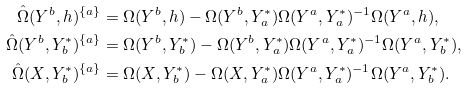Convert formula to latex. <formula><loc_0><loc_0><loc_500><loc_500>\hat { \Omega } ( Y ^ { b } , h ) ^ { \{ a \} } & = \Omega ( Y ^ { b } , h ) - \Omega ( Y ^ { b } , Y ^ { * } _ { a } ) \Omega ( Y ^ { a } , Y ^ { * } _ { a } ) ^ { - 1 } \Omega ( Y ^ { a } , h ) , \\ \hat { \Omega } ( Y ^ { b } , Y ^ { * } _ { b } ) ^ { \{ a \} } & = \Omega ( Y ^ { b } , Y ^ { * } _ { b } ) - \Omega ( Y ^ { b } , Y ^ { * } _ { a } ) \Omega ( Y ^ { a } , Y ^ { * } _ { a } ) ^ { - 1 } \Omega ( Y ^ { a } , Y ^ { * } _ { b } ) , \\ \hat { \Omega } ( X , Y ^ { * } _ { b } ) ^ { \{ a \} } & = \Omega ( X , Y ^ { * } _ { b } ) - \Omega ( X , Y ^ { * } _ { a } ) \Omega ( Y ^ { a } , Y ^ { * } _ { a } ) ^ { - 1 } \Omega ( Y ^ { a } , Y ^ { * } _ { b } ) .</formula> 